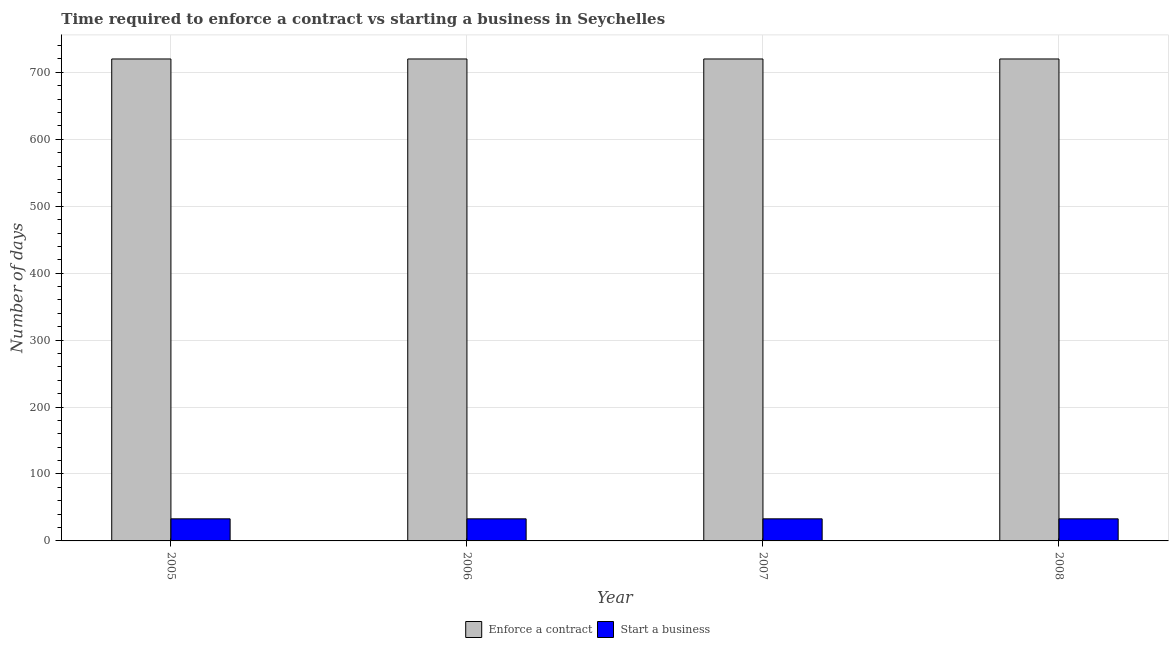How many groups of bars are there?
Keep it short and to the point. 4. How many bars are there on the 3rd tick from the right?
Provide a succinct answer. 2. In how many cases, is the number of bars for a given year not equal to the number of legend labels?
Ensure brevity in your answer.  0. What is the number of days to enforece a contract in 2006?
Provide a short and direct response. 720. Across all years, what is the maximum number of days to start a business?
Give a very brief answer. 33. Across all years, what is the minimum number of days to start a business?
Offer a terse response. 33. In which year was the number of days to enforece a contract maximum?
Provide a succinct answer. 2005. In which year was the number of days to enforece a contract minimum?
Your answer should be compact. 2005. What is the total number of days to start a business in the graph?
Give a very brief answer. 132. What is the difference between the number of days to start a business in 2005 and the number of days to enforece a contract in 2008?
Give a very brief answer. 0. What is the average number of days to enforece a contract per year?
Provide a short and direct response. 720. What is the ratio of the number of days to start a business in 2007 to that in 2008?
Give a very brief answer. 1. Is the number of days to enforece a contract in 2007 less than that in 2008?
Provide a succinct answer. No. Is the difference between the number of days to enforece a contract in 2006 and 2008 greater than the difference between the number of days to start a business in 2006 and 2008?
Your response must be concise. No. What is the difference between the highest and the lowest number of days to start a business?
Your response must be concise. 0. Is the sum of the number of days to enforece a contract in 2006 and 2008 greater than the maximum number of days to start a business across all years?
Make the answer very short. Yes. What does the 1st bar from the left in 2008 represents?
Give a very brief answer. Enforce a contract. What does the 1st bar from the right in 2008 represents?
Your answer should be very brief. Start a business. How many bars are there?
Give a very brief answer. 8. Are all the bars in the graph horizontal?
Offer a terse response. No. How many years are there in the graph?
Your response must be concise. 4. What is the difference between two consecutive major ticks on the Y-axis?
Give a very brief answer. 100. Are the values on the major ticks of Y-axis written in scientific E-notation?
Make the answer very short. No. Where does the legend appear in the graph?
Your answer should be compact. Bottom center. How many legend labels are there?
Keep it short and to the point. 2. What is the title of the graph?
Provide a succinct answer. Time required to enforce a contract vs starting a business in Seychelles. Does "Subsidies" appear as one of the legend labels in the graph?
Your answer should be very brief. No. What is the label or title of the X-axis?
Provide a succinct answer. Year. What is the label or title of the Y-axis?
Offer a terse response. Number of days. What is the Number of days of Enforce a contract in 2005?
Keep it short and to the point. 720. What is the Number of days in Enforce a contract in 2006?
Give a very brief answer. 720. What is the Number of days of Enforce a contract in 2007?
Make the answer very short. 720. What is the Number of days of Enforce a contract in 2008?
Offer a very short reply. 720. Across all years, what is the maximum Number of days of Enforce a contract?
Provide a succinct answer. 720. Across all years, what is the minimum Number of days of Enforce a contract?
Offer a very short reply. 720. Across all years, what is the minimum Number of days of Start a business?
Keep it short and to the point. 33. What is the total Number of days of Enforce a contract in the graph?
Offer a terse response. 2880. What is the total Number of days in Start a business in the graph?
Provide a short and direct response. 132. What is the difference between the Number of days of Enforce a contract in 2005 and that in 2008?
Your answer should be very brief. 0. What is the difference between the Number of days of Start a business in 2005 and that in 2008?
Ensure brevity in your answer.  0. What is the difference between the Number of days in Start a business in 2006 and that in 2007?
Provide a short and direct response. 0. What is the difference between the Number of days in Enforce a contract in 2006 and that in 2008?
Make the answer very short. 0. What is the difference between the Number of days in Enforce a contract in 2005 and the Number of days in Start a business in 2006?
Ensure brevity in your answer.  687. What is the difference between the Number of days in Enforce a contract in 2005 and the Number of days in Start a business in 2007?
Your answer should be compact. 687. What is the difference between the Number of days of Enforce a contract in 2005 and the Number of days of Start a business in 2008?
Your response must be concise. 687. What is the difference between the Number of days of Enforce a contract in 2006 and the Number of days of Start a business in 2007?
Your answer should be compact. 687. What is the difference between the Number of days of Enforce a contract in 2006 and the Number of days of Start a business in 2008?
Your answer should be very brief. 687. What is the difference between the Number of days in Enforce a contract in 2007 and the Number of days in Start a business in 2008?
Offer a very short reply. 687. What is the average Number of days of Enforce a contract per year?
Make the answer very short. 720. What is the average Number of days in Start a business per year?
Provide a short and direct response. 33. In the year 2005, what is the difference between the Number of days in Enforce a contract and Number of days in Start a business?
Offer a very short reply. 687. In the year 2006, what is the difference between the Number of days in Enforce a contract and Number of days in Start a business?
Your answer should be compact. 687. In the year 2007, what is the difference between the Number of days of Enforce a contract and Number of days of Start a business?
Provide a short and direct response. 687. In the year 2008, what is the difference between the Number of days of Enforce a contract and Number of days of Start a business?
Ensure brevity in your answer.  687. What is the ratio of the Number of days of Enforce a contract in 2005 to that in 2007?
Provide a succinct answer. 1. What is the ratio of the Number of days of Start a business in 2005 to that in 2007?
Offer a terse response. 1. What is the ratio of the Number of days of Enforce a contract in 2005 to that in 2008?
Provide a short and direct response. 1. What is the ratio of the Number of days in Start a business in 2006 to that in 2007?
Offer a terse response. 1. What is the difference between the highest and the lowest Number of days in Start a business?
Make the answer very short. 0. 